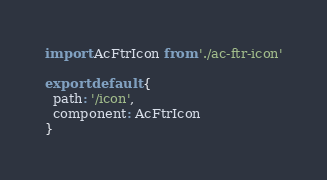<code> <loc_0><loc_0><loc_500><loc_500><_JavaScript_>import AcFtrIcon from './ac-ftr-icon'

export default {
  path: '/icon',
  component: AcFtrIcon
}
</code> 